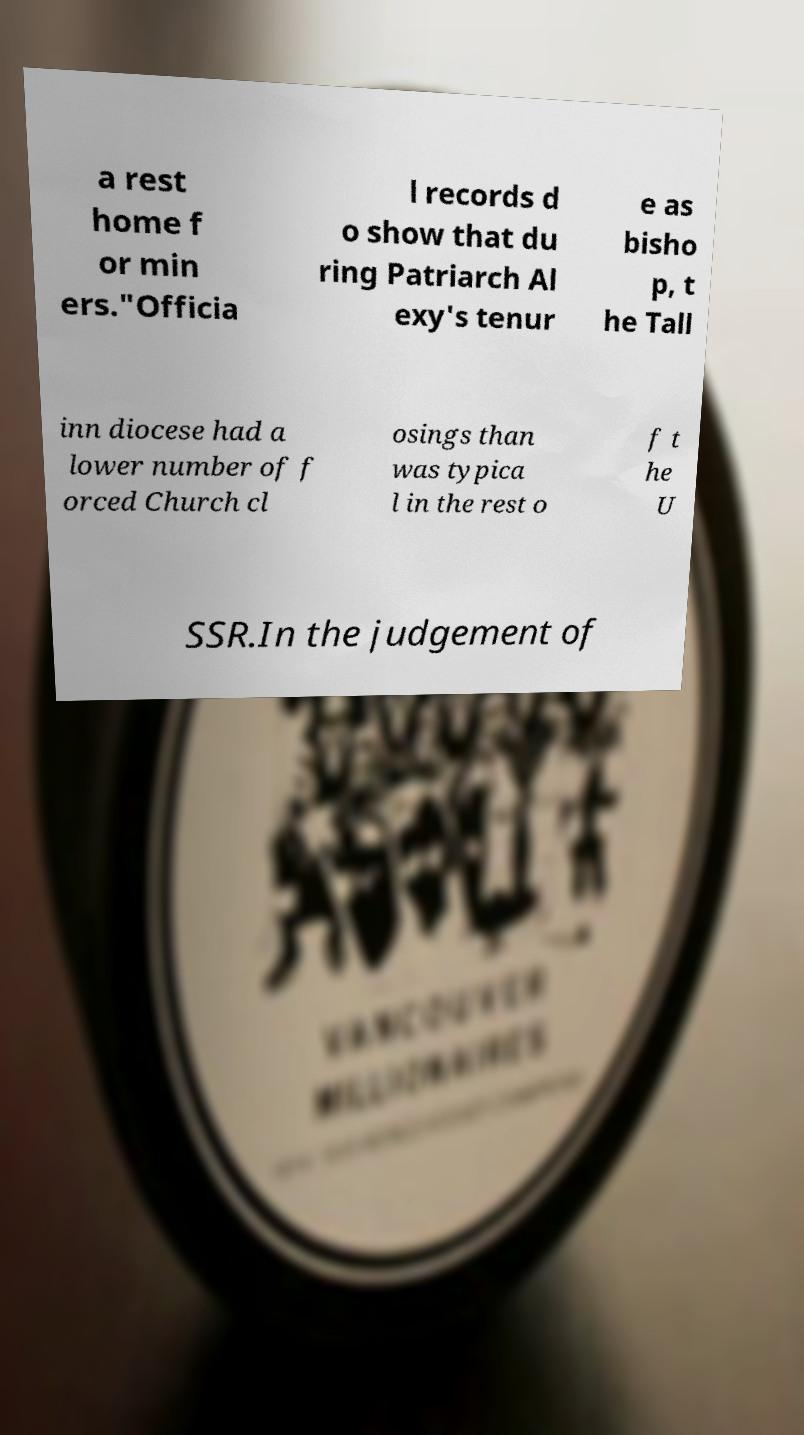Please identify and transcribe the text found in this image. a rest home f or min ers."Officia l records d o show that du ring Patriarch Al exy's tenur e as bisho p, t he Tall inn diocese had a lower number of f orced Church cl osings than was typica l in the rest o f t he U SSR.In the judgement of 